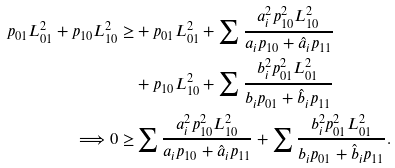<formula> <loc_0><loc_0><loc_500><loc_500>p _ { 0 1 } L _ { 0 1 } ^ { 2 } + p _ { 1 0 } L _ { 1 0 } ^ { 2 } \geq & + p _ { 0 1 } L _ { 0 1 } ^ { 2 } + \sum \frac { a _ { i } ^ { 2 } p _ { 1 0 } ^ { 2 } L _ { 1 0 } ^ { 2 } } { a _ { i } p _ { 1 0 } + \hat { a } _ { i } p _ { 1 1 } } \\ & + p _ { 1 0 } L _ { 1 0 } ^ { 2 } + \sum \frac { b _ { i } ^ { 2 } p _ { 0 1 } ^ { 2 } L _ { 0 1 } ^ { 2 } } { b _ { i } p _ { 0 1 } + \hat { b } _ { i } p _ { 1 1 } } \\ \Longrightarrow 0 \geq & \sum \frac { a _ { i } ^ { 2 } p _ { 1 0 } ^ { 2 } L _ { 1 0 } ^ { 2 } } { a _ { i } p _ { 1 0 } + \hat { a } _ { i } p _ { 1 1 } } + \sum \frac { b _ { i } ^ { 2 } p _ { 0 1 } ^ { 2 } L _ { 0 1 } ^ { 2 } } { b _ { i } p _ { 0 1 } + \hat { b } _ { i } p _ { 1 1 } } .</formula> 